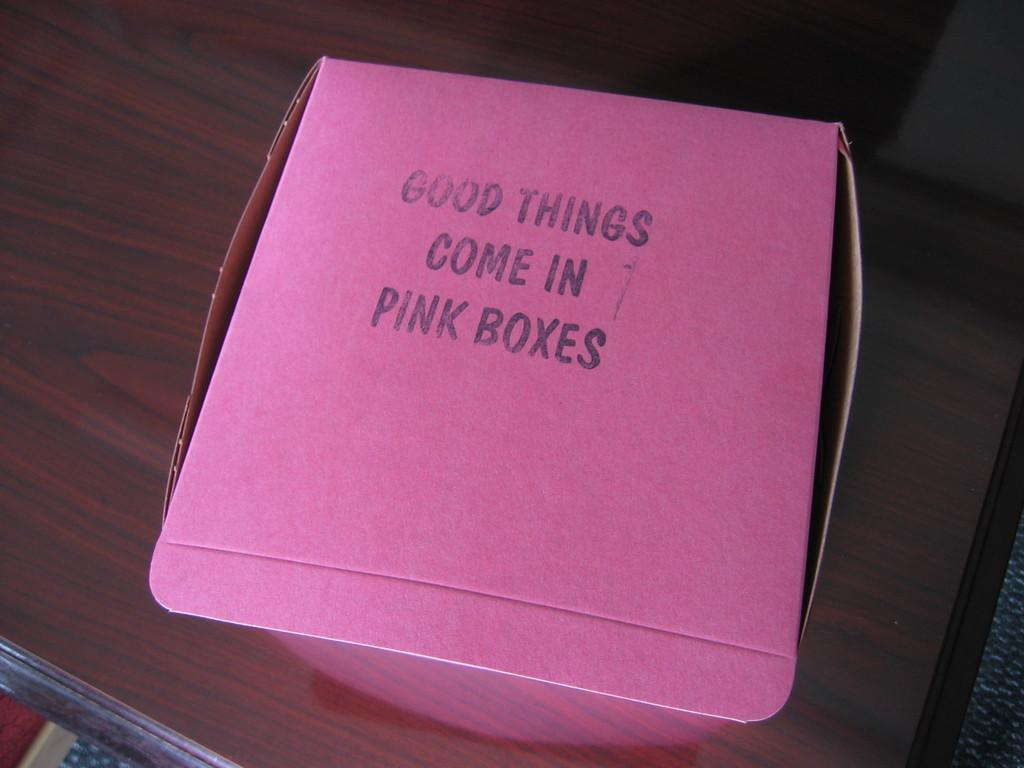<image>
Create a compact narrative representing the image presented. A pink box with Good Thing Come in Pink Boxes written on it. 